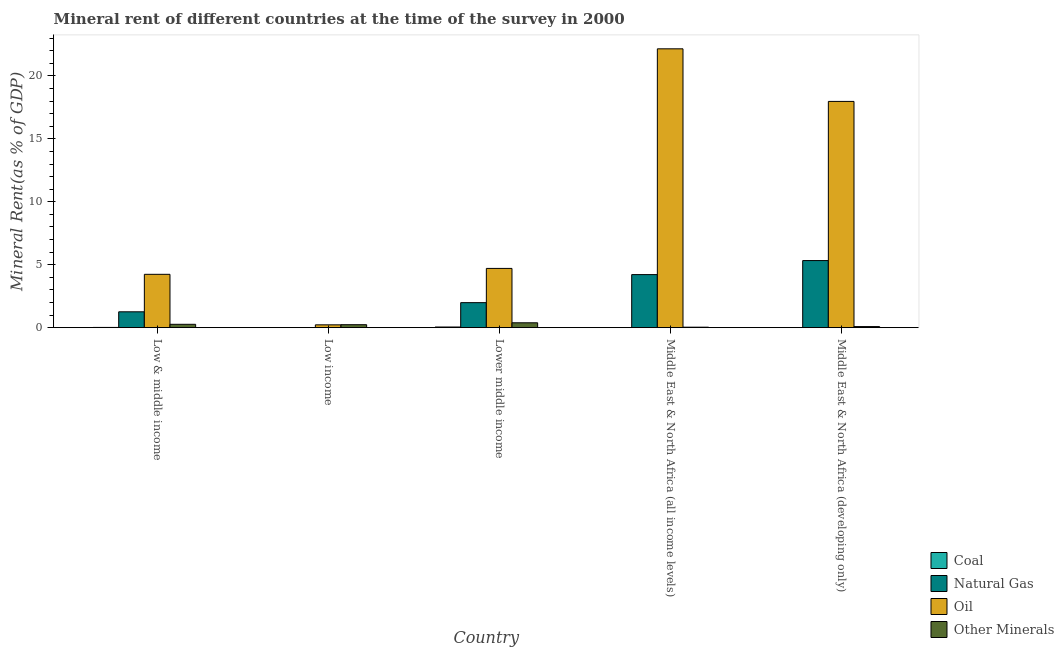Are the number of bars per tick equal to the number of legend labels?
Offer a terse response. Yes. What is the natural gas rent in Middle East & North Africa (developing only)?
Give a very brief answer. 5.33. Across all countries, what is the maximum oil rent?
Make the answer very short. 22.15. Across all countries, what is the minimum  rent of other minerals?
Provide a succinct answer. 0.04. In which country was the oil rent maximum?
Provide a succinct answer. Middle East & North Africa (all income levels). What is the total coal rent in the graph?
Make the answer very short. 0.07. What is the difference between the oil rent in Low & middle income and that in Lower middle income?
Give a very brief answer. -0.47. What is the difference between the natural gas rent in Low income and the  rent of other minerals in Middle East & North Africa (all income levels)?
Provide a short and direct response. -0.04. What is the average natural gas rent per country?
Make the answer very short. 2.56. What is the difference between the coal rent and oil rent in Low & middle income?
Offer a very short reply. -4.22. What is the ratio of the coal rent in Low income to that in Middle East & North Africa (all income levels)?
Offer a very short reply. 0.12. Is the  rent of other minerals in Low & middle income less than that in Middle East & North Africa (all income levels)?
Provide a succinct answer. No. What is the difference between the highest and the second highest oil rent?
Provide a succinct answer. 4.18. What is the difference between the highest and the lowest oil rent?
Offer a very short reply. 21.93. In how many countries, is the coal rent greater than the average coal rent taken over all countries?
Your answer should be compact. 2. Is the sum of the  rent of other minerals in Lower middle income and Middle East & North Africa (all income levels) greater than the maximum coal rent across all countries?
Offer a very short reply. Yes. Is it the case that in every country, the sum of the coal rent and natural gas rent is greater than the sum of  rent of other minerals and oil rent?
Your answer should be compact. No. What does the 3rd bar from the left in Lower middle income represents?
Provide a short and direct response. Oil. What does the 4th bar from the right in Middle East & North Africa (developing only) represents?
Give a very brief answer. Coal. Is it the case that in every country, the sum of the coal rent and natural gas rent is greater than the oil rent?
Your response must be concise. No. How many bars are there?
Ensure brevity in your answer.  20. Does the graph contain grids?
Your response must be concise. No. Where does the legend appear in the graph?
Provide a short and direct response. Bottom right. How are the legend labels stacked?
Provide a short and direct response. Vertical. What is the title of the graph?
Make the answer very short. Mineral rent of different countries at the time of the survey in 2000. Does "Public resource use" appear as one of the legend labels in the graph?
Your response must be concise. No. What is the label or title of the X-axis?
Offer a very short reply. Country. What is the label or title of the Y-axis?
Give a very brief answer. Mineral Rent(as % of GDP). What is the Mineral Rent(as % of GDP) of Coal in Low & middle income?
Give a very brief answer. 0.02. What is the Mineral Rent(as % of GDP) of Natural Gas in Low & middle income?
Provide a short and direct response. 1.26. What is the Mineral Rent(as % of GDP) in Oil in Low & middle income?
Give a very brief answer. 4.24. What is the Mineral Rent(as % of GDP) of Other Minerals in Low & middle income?
Give a very brief answer. 0.27. What is the Mineral Rent(as % of GDP) of Coal in Low income?
Offer a very short reply. 3.43081541094935e-5. What is the Mineral Rent(as % of GDP) of Natural Gas in Low income?
Offer a very short reply. 0. What is the Mineral Rent(as % of GDP) of Oil in Low income?
Your answer should be very brief. 0.22. What is the Mineral Rent(as % of GDP) of Other Minerals in Low income?
Offer a terse response. 0.24. What is the Mineral Rent(as % of GDP) of Coal in Lower middle income?
Keep it short and to the point. 0.05. What is the Mineral Rent(as % of GDP) of Natural Gas in Lower middle income?
Your answer should be very brief. 1.99. What is the Mineral Rent(as % of GDP) in Oil in Lower middle income?
Give a very brief answer. 4.71. What is the Mineral Rent(as % of GDP) in Other Minerals in Lower middle income?
Your answer should be compact. 0.39. What is the Mineral Rent(as % of GDP) in Coal in Middle East & North Africa (all income levels)?
Your answer should be very brief. 0. What is the Mineral Rent(as % of GDP) in Natural Gas in Middle East & North Africa (all income levels)?
Give a very brief answer. 4.22. What is the Mineral Rent(as % of GDP) of Oil in Middle East & North Africa (all income levels)?
Give a very brief answer. 22.15. What is the Mineral Rent(as % of GDP) in Other Minerals in Middle East & North Africa (all income levels)?
Offer a terse response. 0.04. What is the Mineral Rent(as % of GDP) in Coal in Middle East & North Africa (developing only)?
Offer a very short reply. 0. What is the Mineral Rent(as % of GDP) in Natural Gas in Middle East & North Africa (developing only)?
Offer a terse response. 5.33. What is the Mineral Rent(as % of GDP) in Oil in Middle East & North Africa (developing only)?
Offer a very short reply. 17.97. What is the Mineral Rent(as % of GDP) of Other Minerals in Middle East & North Africa (developing only)?
Give a very brief answer. 0.09. Across all countries, what is the maximum Mineral Rent(as % of GDP) in Coal?
Your answer should be very brief. 0.05. Across all countries, what is the maximum Mineral Rent(as % of GDP) of Natural Gas?
Offer a very short reply. 5.33. Across all countries, what is the maximum Mineral Rent(as % of GDP) of Oil?
Keep it short and to the point. 22.15. Across all countries, what is the maximum Mineral Rent(as % of GDP) in Other Minerals?
Give a very brief answer. 0.39. Across all countries, what is the minimum Mineral Rent(as % of GDP) of Coal?
Your answer should be very brief. 3.43081541094935e-5. Across all countries, what is the minimum Mineral Rent(as % of GDP) of Natural Gas?
Give a very brief answer. 0. Across all countries, what is the minimum Mineral Rent(as % of GDP) of Oil?
Your answer should be compact. 0.22. Across all countries, what is the minimum Mineral Rent(as % of GDP) of Other Minerals?
Keep it short and to the point. 0.04. What is the total Mineral Rent(as % of GDP) in Coal in the graph?
Offer a terse response. 0.07. What is the total Mineral Rent(as % of GDP) of Natural Gas in the graph?
Give a very brief answer. 12.79. What is the total Mineral Rent(as % of GDP) in Oil in the graph?
Your response must be concise. 49.3. What is the total Mineral Rent(as % of GDP) of Other Minerals in the graph?
Provide a succinct answer. 1.01. What is the difference between the Mineral Rent(as % of GDP) of Coal in Low & middle income and that in Low income?
Provide a short and direct response. 0.02. What is the difference between the Mineral Rent(as % of GDP) in Natural Gas in Low & middle income and that in Low income?
Make the answer very short. 1.26. What is the difference between the Mineral Rent(as % of GDP) in Oil in Low & middle income and that in Low income?
Give a very brief answer. 4.01. What is the difference between the Mineral Rent(as % of GDP) of Other Minerals in Low & middle income and that in Low income?
Ensure brevity in your answer.  0.03. What is the difference between the Mineral Rent(as % of GDP) of Coal in Low & middle income and that in Lower middle income?
Provide a succinct answer. -0.03. What is the difference between the Mineral Rent(as % of GDP) in Natural Gas in Low & middle income and that in Lower middle income?
Make the answer very short. -0.73. What is the difference between the Mineral Rent(as % of GDP) in Oil in Low & middle income and that in Lower middle income?
Ensure brevity in your answer.  -0.47. What is the difference between the Mineral Rent(as % of GDP) in Other Minerals in Low & middle income and that in Lower middle income?
Keep it short and to the point. -0.12. What is the difference between the Mineral Rent(as % of GDP) in Coal in Low & middle income and that in Middle East & North Africa (all income levels)?
Provide a short and direct response. 0.02. What is the difference between the Mineral Rent(as % of GDP) in Natural Gas in Low & middle income and that in Middle East & North Africa (all income levels)?
Provide a short and direct response. -2.96. What is the difference between the Mineral Rent(as % of GDP) of Oil in Low & middle income and that in Middle East & North Africa (all income levels)?
Provide a succinct answer. -17.91. What is the difference between the Mineral Rent(as % of GDP) of Other Minerals in Low & middle income and that in Middle East & North Africa (all income levels)?
Make the answer very short. 0.23. What is the difference between the Mineral Rent(as % of GDP) of Coal in Low & middle income and that in Middle East & North Africa (developing only)?
Provide a short and direct response. 0.02. What is the difference between the Mineral Rent(as % of GDP) of Natural Gas in Low & middle income and that in Middle East & North Africa (developing only)?
Ensure brevity in your answer.  -4.07. What is the difference between the Mineral Rent(as % of GDP) of Oil in Low & middle income and that in Middle East & North Africa (developing only)?
Provide a short and direct response. -13.74. What is the difference between the Mineral Rent(as % of GDP) in Other Minerals in Low & middle income and that in Middle East & North Africa (developing only)?
Ensure brevity in your answer.  0.18. What is the difference between the Mineral Rent(as % of GDP) of Coal in Low income and that in Lower middle income?
Offer a very short reply. -0.05. What is the difference between the Mineral Rent(as % of GDP) of Natural Gas in Low income and that in Lower middle income?
Offer a very short reply. -1.99. What is the difference between the Mineral Rent(as % of GDP) of Oil in Low income and that in Lower middle income?
Your response must be concise. -4.48. What is the difference between the Mineral Rent(as % of GDP) in Other Minerals in Low income and that in Lower middle income?
Provide a short and direct response. -0.15. What is the difference between the Mineral Rent(as % of GDP) in Coal in Low income and that in Middle East & North Africa (all income levels)?
Offer a very short reply. -0. What is the difference between the Mineral Rent(as % of GDP) of Natural Gas in Low income and that in Middle East & North Africa (all income levels)?
Offer a very short reply. -4.22. What is the difference between the Mineral Rent(as % of GDP) of Oil in Low income and that in Middle East & North Africa (all income levels)?
Provide a succinct answer. -21.93. What is the difference between the Mineral Rent(as % of GDP) in Other Minerals in Low income and that in Middle East & North Africa (all income levels)?
Offer a terse response. 0.2. What is the difference between the Mineral Rent(as % of GDP) in Coal in Low income and that in Middle East & North Africa (developing only)?
Ensure brevity in your answer.  -0. What is the difference between the Mineral Rent(as % of GDP) in Natural Gas in Low income and that in Middle East & North Africa (developing only)?
Your answer should be very brief. -5.33. What is the difference between the Mineral Rent(as % of GDP) of Oil in Low income and that in Middle East & North Africa (developing only)?
Ensure brevity in your answer.  -17.75. What is the difference between the Mineral Rent(as % of GDP) in Other Minerals in Low income and that in Middle East & North Africa (developing only)?
Make the answer very short. 0.15. What is the difference between the Mineral Rent(as % of GDP) of Coal in Lower middle income and that in Middle East & North Africa (all income levels)?
Keep it short and to the point. 0.05. What is the difference between the Mineral Rent(as % of GDP) of Natural Gas in Lower middle income and that in Middle East & North Africa (all income levels)?
Keep it short and to the point. -2.23. What is the difference between the Mineral Rent(as % of GDP) of Oil in Lower middle income and that in Middle East & North Africa (all income levels)?
Your answer should be very brief. -17.45. What is the difference between the Mineral Rent(as % of GDP) of Other Minerals in Lower middle income and that in Middle East & North Africa (all income levels)?
Make the answer very short. 0.35. What is the difference between the Mineral Rent(as % of GDP) in Coal in Lower middle income and that in Middle East & North Africa (developing only)?
Your answer should be compact. 0.05. What is the difference between the Mineral Rent(as % of GDP) of Natural Gas in Lower middle income and that in Middle East & North Africa (developing only)?
Keep it short and to the point. -3.34. What is the difference between the Mineral Rent(as % of GDP) in Oil in Lower middle income and that in Middle East & North Africa (developing only)?
Provide a short and direct response. -13.27. What is the difference between the Mineral Rent(as % of GDP) of Other Minerals in Lower middle income and that in Middle East & North Africa (developing only)?
Make the answer very short. 0.3. What is the difference between the Mineral Rent(as % of GDP) of Coal in Middle East & North Africa (all income levels) and that in Middle East & North Africa (developing only)?
Offer a very short reply. -0. What is the difference between the Mineral Rent(as % of GDP) of Natural Gas in Middle East & North Africa (all income levels) and that in Middle East & North Africa (developing only)?
Keep it short and to the point. -1.12. What is the difference between the Mineral Rent(as % of GDP) in Oil in Middle East & North Africa (all income levels) and that in Middle East & North Africa (developing only)?
Offer a terse response. 4.18. What is the difference between the Mineral Rent(as % of GDP) in Other Minerals in Middle East & North Africa (all income levels) and that in Middle East & North Africa (developing only)?
Your answer should be compact. -0.05. What is the difference between the Mineral Rent(as % of GDP) in Coal in Low & middle income and the Mineral Rent(as % of GDP) in Natural Gas in Low income?
Offer a terse response. 0.02. What is the difference between the Mineral Rent(as % of GDP) in Coal in Low & middle income and the Mineral Rent(as % of GDP) in Oil in Low income?
Your answer should be compact. -0.21. What is the difference between the Mineral Rent(as % of GDP) of Coal in Low & middle income and the Mineral Rent(as % of GDP) of Other Minerals in Low income?
Ensure brevity in your answer.  -0.22. What is the difference between the Mineral Rent(as % of GDP) of Natural Gas in Low & middle income and the Mineral Rent(as % of GDP) of Oil in Low income?
Your response must be concise. 1.04. What is the difference between the Mineral Rent(as % of GDP) in Natural Gas in Low & middle income and the Mineral Rent(as % of GDP) in Other Minerals in Low income?
Make the answer very short. 1.02. What is the difference between the Mineral Rent(as % of GDP) in Oil in Low & middle income and the Mineral Rent(as % of GDP) in Other Minerals in Low income?
Your response must be concise. 4. What is the difference between the Mineral Rent(as % of GDP) of Coal in Low & middle income and the Mineral Rent(as % of GDP) of Natural Gas in Lower middle income?
Offer a terse response. -1.97. What is the difference between the Mineral Rent(as % of GDP) of Coal in Low & middle income and the Mineral Rent(as % of GDP) of Oil in Lower middle income?
Your response must be concise. -4.69. What is the difference between the Mineral Rent(as % of GDP) in Coal in Low & middle income and the Mineral Rent(as % of GDP) in Other Minerals in Lower middle income?
Offer a terse response. -0.37. What is the difference between the Mineral Rent(as % of GDP) in Natural Gas in Low & middle income and the Mineral Rent(as % of GDP) in Oil in Lower middle income?
Your answer should be very brief. -3.45. What is the difference between the Mineral Rent(as % of GDP) in Natural Gas in Low & middle income and the Mineral Rent(as % of GDP) in Other Minerals in Lower middle income?
Provide a succinct answer. 0.87. What is the difference between the Mineral Rent(as % of GDP) in Oil in Low & middle income and the Mineral Rent(as % of GDP) in Other Minerals in Lower middle income?
Offer a very short reply. 3.85. What is the difference between the Mineral Rent(as % of GDP) in Coal in Low & middle income and the Mineral Rent(as % of GDP) in Natural Gas in Middle East & North Africa (all income levels)?
Provide a short and direct response. -4.2. What is the difference between the Mineral Rent(as % of GDP) in Coal in Low & middle income and the Mineral Rent(as % of GDP) in Oil in Middle East & North Africa (all income levels)?
Ensure brevity in your answer.  -22.13. What is the difference between the Mineral Rent(as % of GDP) in Coal in Low & middle income and the Mineral Rent(as % of GDP) in Other Minerals in Middle East & North Africa (all income levels)?
Provide a short and direct response. -0.02. What is the difference between the Mineral Rent(as % of GDP) in Natural Gas in Low & middle income and the Mineral Rent(as % of GDP) in Oil in Middle East & North Africa (all income levels)?
Your answer should be very brief. -20.89. What is the difference between the Mineral Rent(as % of GDP) of Natural Gas in Low & middle income and the Mineral Rent(as % of GDP) of Other Minerals in Middle East & North Africa (all income levels)?
Your response must be concise. 1.22. What is the difference between the Mineral Rent(as % of GDP) in Oil in Low & middle income and the Mineral Rent(as % of GDP) in Other Minerals in Middle East & North Africa (all income levels)?
Offer a very short reply. 4.2. What is the difference between the Mineral Rent(as % of GDP) of Coal in Low & middle income and the Mineral Rent(as % of GDP) of Natural Gas in Middle East & North Africa (developing only)?
Make the answer very short. -5.31. What is the difference between the Mineral Rent(as % of GDP) in Coal in Low & middle income and the Mineral Rent(as % of GDP) in Oil in Middle East & North Africa (developing only)?
Give a very brief answer. -17.96. What is the difference between the Mineral Rent(as % of GDP) in Coal in Low & middle income and the Mineral Rent(as % of GDP) in Other Minerals in Middle East & North Africa (developing only)?
Ensure brevity in your answer.  -0.07. What is the difference between the Mineral Rent(as % of GDP) in Natural Gas in Low & middle income and the Mineral Rent(as % of GDP) in Oil in Middle East & North Africa (developing only)?
Give a very brief answer. -16.71. What is the difference between the Mineral Rent(as % of GDP) of Natural Gas in Low & middle income and the Mineral Rent(as % of GDP) of Other Minerals in Middle East & North Africa (developing only)?
Keep it short and to the point. 1.17. What is the difference between the Mineral Rent(as % of GDP) in Oil in Low & middle income and the Mineral Rent(as % of GDP) in Other Minerals in Middle East & North Africa (developing only)?
Offer a very short reply. 4.15. What is the difference between the Mineral Rent(as % of GDP) of Coal in Low income and the Mineral Rent(as % of GDP) of Natural Gas in Lower middle income?
Keep it short and to the point. -1.99. What is the difference between the Mineral Rent(as % of GDP) in Coal in Low income and the Mineral Rent(as % of GDP) in Oil in Lower middle income?
Provide a succinct answer. -4.71. What is the difference between the Mineral Rent(as % of GDP) of Coal in Low income and the Mineral Rent(as % of GDP) of Other Minerals in Lower middle income?
Your answer should be compact. -0.39. What is the difference between the Mineral Rent(as % of GDP) in Natural Gas in Low income and the Mineral Rent(as % of GDP) in Oil in Lower middle income?
Your answer should be very brief. -4.71. What is the difference between the Mineral Rent(as % of GDP) in Natural Gas in Low income and the Mineral Rent(as % of GDP) in Other Minerals in Lower middle income?
Provide a succinct answer. -0.39. What is the difference between the Mineral Rent(as % of GDP) in Oil in Low income and the Mineral Rent(as % of GDP) in Other Minerals in Lower middle income?
Ensure brevity in your answer.  -0.16. What is the difference between the Mineral Rent(as % of GDP) of Coal in Low income and the Mineral Rent(as % of GDP) of Natural Gas in Middle East & North Africa (all income levels)?
Keep it short and to the point. -4.22. What is the difference between the Mineral Rent(as % of GDP) in Coal in Low income and the Mineral Rent(as % of GDP) in Oil in Middle East & North Africa (all income levels)?
Your response must be concise. -22.15. What is the difference between the Mineral Rent(as % of GDP) in Coal in Low income and the Mineral Rent(as % of GDP) in Other Minerals in Middle East & North Africa (all income levels)?
Offer a very short reply. -0.04. What is the difference between the Mineral Rent(as % of GDP) of Natural Gas in Low income and the Mineral Rent(as % of GDP) of Oil in Middle East & North Africa (all income levels)?
Your answer should be compact. -22.15. What is the difference between the Mineral Rent(as % of GDP) in Natural Gas in Low income and the Mineral Rent(as % of GDP) in Other Minerals in Middle East & North Africa (all income levels)?
Your answer should be very brief. -0.04. What is the difference between the Mineral Rent(as % of GDP) in Oil in Low income and the Mineral Rent(as % of GDP) in Other Minerals in Middle East & North Africa (all income levels)?
Provide a short and direct response. 0.19. What is the difference between the Mineral Rent(as % of GDP) in Coal in Low income and the Mineral Rent(as % of GDP) in Natural Gas in Middle East & North Africa (developing only)?
Make the answer very short. -5.33. What is the difference between the Mineral Rent(as % of GDP) of Coal in Low income and the Mineral Rent(as % of GDP) of Oil in Middle East & North Africa (developing only)?
Ensure brevity in your answer.  -17.97. What is the difference between the Mineral Rent(as % of GDP) of Coal in Low income and the Mineral Rent(as % of GDP) of Other Minerals in Middle East & North Africa (developing only)?
Your response must be concise. -0.09. What is the difference between the Mineral Rent(as % of GDP) of Natural Gas in Low income and the Mineral Rent(as % of GDP) of Oil in Middle East & North Africa (developing only)?
Provide a short and direct response. -17.97. What is the difference between the Mineral Rent(as % of GDP) of Natural Gas in Low income and the Mineral Rent(as % of GDP) of Other Minerals in Middle East & North Africa (developing only)?
Offer a terse response. -0.09. What is the difference between the Mineral Rent(as % of GDP) in Oil in Low income and the Mineral Rent(as % of GDP) in Other Minerals in Middle East & North Africa (developing only)?
Your answer should be compact. 0.14. What is the difference between the Mineral Rent(as % of GDP) in Coal in Lower middle income and the Mineral Rent(as % of GDP) in Natural Gas in Middle East & North Africa (all income levels)?
Provide a short and direct response. -4.16. What is the difference between the Mineral Rent(as % of GDP) in Coal in Lower middle income and the Mineral Rent(as % of GDP) in Oil in Middle East & North Africa (all income levels)?
Offer a terse response. -22.1. What is the difference between the Mineral Rent(as % of GDP) in Coal in Lower middle income and the Mineral Rent(as % of GDP) in Other Minerals in Middle East & North Africa (all income levels)?
Your answer should be very brief. 0.01. What is the difference between the Mineral Rent(as % of GDP) of Natural Gas in Lower middle income and the Mineral Rent(as % of GDP) of Oil in Middle East & North Africa (all income levels)?
Make the answer very short. -20.17. What is the difference between the Mineral Rent(as % of GDP) in Natural Gas in Lower middle income and the Mineral Rent(as % of GDP) in Other Minerals in Middle East & North Africa (all income levels)?
Provide a short and direct response. 1.95. What is the difference between the Mineral Rent(as % of GDP) of Oil in Lower middle income and the Mineral Rent(as % of GDP) of Other Minerals in Middle East & North Africa (all income levels)?
Offer a very short reply. 4.67. What is the difference between the Mineral Rent(as % of GDP) in Coal in Lower middle income and the Mineral Rent(as % of GDP) in Natural Gas in Middle East & North Africa (developing only)?
Your answer should be compact. -5.28. What is the difference between the Mineral Rent(as % of GDP) of Coal in Lower middle income and the Mineral Rent(as % of GDP) of Oil in Middle East & North Africa (developing only)?
Provide a succinct answer. -17.92. What is the difference between the Mineral Rent(as % of GDP) of Coal in Lower middle income and the Mineral Rent(as % of GDP) of Other Minerals in Middle East & North Africa (developing only)?
Your answer should be very brief. -0.03. What is the difference between the Mineral Rent(as % of GDP) of Natural Gas in Lower middle income and the Mineral Rent(as % of GDP) of Oil in Middle East & North Africa (developing only)?
Provide a succinct answer. -15.99. What is the difference between the Mineral Rent(as % of GDP) in Natural Gas in Lower middle income and the Mineral Rent(as % of GDP) in Other Minerals in Middle East & North Africa (developing only)?
Provide a short and direct response. 1.9. What is the difference between the Mineral Rent(as % of GDP) in Oil in Lower middle income and the Mineral Rent(as % of GDP) in Other Minerals in Middle East & North Africa (developing only)?
Give a very brief answer. 4.62. What is the difference between the Mineral Rent(as % of GDP) in Coal in Middle East & North Africa (all income levels) and the Mineral Rent(as % of GDP) in Natural Gas in Middle East & North Africa (developing only)?
Offer a very short reply. -5.33. What is the difference between the Mineral Rent(as % of GDP) of Coal in Middle East & North Africa (all income levels) and the Mineral Rent(as % of GDP) of Oil in Middle East & North Africa (developing only)?
Provide a short and direct response. -17.97. What is the difference between the Mineral Rent(as % of GDP) in Coal in Middle East & North Africa (all income levels) and the Mineral Rent(as % of GDP) in Other Minerals in Middle East & North Africa (developing only)?
Ensure brevity in your answer.  -0.08. What is the difference between the Mineral Rent(as % of GDP) in Natural Gas in Middle East & North Africa (all income levels) and the Mineral Rent(as % of GDP) in Oil in Middle East & North Africa (developing only)?
Provide a short and direct response. -13.76. What is the difference between the Mineral Rent(as % of GDP) in Natural Gas in Middle East & North Africa (all income levels) and the Mineral Rent(as % of GDP) in Other Minerals in Middle East & North Africa (developing only)?
Your answer should be compact. 4.13. What is the difference between the Mineral Rent(as % of GDP) of Oil in Middle East & North Africa (all income levels) and the Mineral Rent(as % of GDP) of Other Minerals in Middle East & North Africa (developing only)?
Provide a succinct answer. 22.07. What is the average Mineral Rent(as % of GDP) in Coal per country?
Your answer should be very brief. 0.01. What is the average Mineral Rent(as % of GDP) in Natural Gas per country?
Give a very brief answer. 2.56. What is the average Mineral Rent(as % of GDP) in Oil per country?
Your answer should be very brief. 9.86. What is the average Mineral Rent(as % of GDP) of Other Minerals per country?
Provide a succinct answer. 0.2. What is the difference between the Mineral Rent(as % of GDP) of Coal and Mineral Rent(as % of GDP) of Natural Gas in Low & middle income?
Ensure brevity in your answer.  -1.24. What is the difference between the Mineral Rent(as % of GDP) in Coal and Mineral Rent(as % of GDP) in Oil in Low & middle income?
Offer a terse response. -4.22. What is the difference between the Mineral Rent(as % of GDP) of Coal and Mineral Rent(as % of GDP) of Other Minerals in Low & middle income?
Offer a terse response. -0.25. What is the difference between the Mineral Rent(as % of GDP) of Natural Gas and Mineral Rent(as % of GDP) of Oil in Low & middle income?
Your response must be concise. -2.98. What is the difference between the Mineral Rent(as % of GDP) of Natural Gas and Mineral Rent(as % of GDP) of Other Minerals in Low & middle income?
Make the answer very short. 0.99. What is the difference between the Mineral Rent(as % of GDP) of Oil and Mineral Rent(as % of GDP) of Other Minerals in Low & middle income?
Keep it short and to the point. 3.97. What is the difference between the Mineral Rent(as % of GDP) in Coal and Mineral Rent(as % of GDP) in Natural Gas in Low income?
Ensure brevity in your answer.  -0. What is the difference between the Mineral Rent(as % of GDP) in Coal and Mineral Rent(as % of GDP) in Oil in Low income?
Offer a very short reply. -0.22. What is the difference between the Mineral Rent(as % of GDP) in Coal and Mineral Rent(as % of GDP) in Other Minerals in Low income?
Provide a succinct answer. -0.24. What is the difference between the Mineral Rent(as % of GDP) in Natural Gas and Mineral Rent(as % of GDP) in Oil in Low income?
Give a very brief answer. -0.22. What is the difference between the Mineral Rent(as % of GDP) of Natural Gas and Mineral Rent(as % of GDP) of Other Minerals in Low income?
Give a very brief answer. -0.24. What is the difference between the Mineral Rent(as % of GDP) of Oil and Mineral Rent(as % of GDP) of Other Minerals in Low income?
Make the answer very short. -0.01. What is the difference between the Mineral Rent(as % of GDP) of Coal and Mineral Rent(as % of GDP) of Natural Gas in Lower middle income?
Provide a short and direct response. -1.93. What is the difference between the Mineral Rent(as % of GDP) in Coal and Mineral Rent(as % of GDP) in Oil in Lower middle income?
Offer a terse response. -4.65. What is the difference between the Mineral Rent(as % of GDP) of Coal and Mineral Rent(as % of GDP) of Other Minerals in Lower middle income?
Make the answer very short. -0.33. What is the difference between the Mineral Rent(as % of GDP) in Natural Gas and Mineral Rent(as % of GDP) in Oil in Lower middle income?
Your answer should be very brief. -2.72. What is the difference between the Mineral Rent(as % of GDP) in Natural Gas and Mineral Rent(as % of GDP) in Other Minerals in Lower middle income?
Your answer should be very brief. 1.6. What is the difference between the Mineral Rent(as % of GDP) of Oil and Mineral Rent(as % of GDP) of Other Minerals in Lower middle income?
Keep it short and to the point. 4.32. What is the difference between the Mineral Rent(as % of GDP) of Coal and Mineral Rent(as % of GDP) of Natural Gas in Middle East & North Africa (all income levels)?
Your response must be concise. -4.22. What is the difference between the Mineral Rent(as % of GDP) of Coal and Mineral Rent(as % of GDP) of Oil in Middle East & North Africa (all income levels)?
Give a very brief answer. -22.15. What is the difference between the Mineral Rent(as % of GDP) in Coal and Mineral Rent(as % of GDP) in Other Minerals in Middle East & North Africa (all income levels)?
Provide a succinct answer. -0.04. What is the difference between the Mineral Rent(as % of GDP) of Natural Gas and Mineral Rent(as % of GDP) of Oil in Middle East & North Africa (all income levels)?
Provide a succinct answer. -17.94. What is the difference between the Mineral Rent(as % of GDP) of Natural Gas and Mineral Rent(as % of GDP) of Other Minerals in Middle East & North Africa (all income levels)?
Ensure brevity in your answer.  4.18. What is the difference between the Mineral Rent(as % of GDP) of Oil and Mineral Rent(as % of GDP) of Other Minerals in Middle East & North Africa (all income levels)?
Your answer should be very brief. 22.11. What is the difference between the Mineral Rent(as % of GDP) in Coal and Mineral Rent(as % of GDP) in Natural Gas in Middle East & North Africa (developing only)?
Offer a terse response. -5.33. What is the difference between the Mineral Rent(as % of GDP) of Coal and Mineral Rent(as % of GDP) of Oil in Middle East & North Africa (developing only)?
Ensure brevity in your answer.  -17.97. What is the difference between the Mineral Rent(as % of GDP) in Coal and Mineral Rent(as % of GDP) in Other Minerals in Middle East & North Africa (developing only)?
Your answer should be very brief. -0.08. What is the difference between the Mineral Rent(as % of GDP) in Natural Gas and Mineral Rent(as % of GDP) in Oil in Middle East & North Africa (developing only)?
Provide a succinct answer. -12.64. What is the difference between the Mineral Rent(as % of GDP) in Natural Gas and Mineral Rent(as % of GDP) in Other Minerals in Middle East & North Africa (developing only)?
Provide a succinct answer. 5.25. What is the difference between the Mineral Rent(as % of GDP) in Oil and Mineral Rent(as % of GDP) in Other Minerals in Middle East & North Africa (developing only)?
Your response must be concise. 17.89. What is the ratio of the Mineral Rent(as % of GDP) in Coal in Low & middle income to that in Low income?
Make the answer very short. 547.49. What is the ratio of the Mineral Rent(as % of GDP) of Natural Gas in Low & middle income to that in Low income?
Provide a short and direct response. 8492.11. What is the ratio of the Mineral Rent(as % of GDP) in Oil in Low & middle income to that in Low income?
Provide a succinct answer. 18.89. What is the ratio of the Mineral Rent(as % of GDP) in Other Minerals in Low & middle income to that in Low income?
Ensure brevity in your answer.  1.13. What is the ratio of the Mineral Rent(as % of GDP) in Coal in Low & middle income to that in Lower middle income?
Give a very brief answer. 0.36. What is the ratio of the Mineral Rent(as % of GDP) of Natural Gas in Low & middle income to that in Lower middle income?
Offer a terse response. 0.63. What is the ratio of the Mineral Rent(as % of GDP) in Oil in Low & middle income to that in Lower middle income?
Provide a short and direct response. 0.9. What is the ratio of the Mineral Rent(as % of GDP) in Other Minerals in Low & middle income to that in Lower middle income?
Your answer should be compact. 0.69. What is the ratio of the Mineral Rent(as % of GDP) in Coal in Low & middle income to that in Middle East & North Africa (all income levels)?
Provide a succinct answer. 65.83. What is the ratio of the Mineral Rent(as % of GDP) of Natural Gas in Low & middle income to that in Middle East & North Africa (all income levels)?
Offer a very short reply. 0.3. What is the ratio of the Mineral Rent(as % of GDP) in Oil in Low & middle income to that in Middle East & North Africa (all income levels)?
Your response must be concise. 0.19. What is the ratio of the Mineral Rent(as % of GDP) in Other Minerals in Low & middle income to that in Middle East & North Africa (all income levels)?
Provide a succinct answer. 6.92. What is the ratio of the Mineral Rent(as % of GDP) in Coal in Low & middle income to that in Middle East & North Africa (developing only)?
Your answer should be compact. 29.65. What is the ratio of the Mineral Rent(as % of GDP) of Natural Gas in Low & middle income to that in Middle East & North Africa (developing only)?
Your answer should be very brief. 0.24. What is the ratio of the Mineral Rent(as % of GDP) in Oil in Low & middle income to that in Middle East & North Africa (developing only)?
Your answer should be compact. 0.24. What is the ratio of the Mineral Rent(as % of GDP) of Other Minerals in Low & middle income to that in Middle East & North Africa (developing only)?
Provide a short and direct response. 3.13. What is the ratio of the Mineral Rent(as % of GDP) in Coal in Low income to that in Lower middle income?
Provide a short and direct response. 0. What is the ratio of the Mineral Rent(as % of GDP) of Oil in Low income to that in Lower middle income?
Ensure brevity in your answer.  0.05. What is the ratio of the Mineral Rent(as % of GDP) of Other Minerals in Low income to that in Lower middle income?
Offer a terse response. 0.61. What is the ratio of the Mineral Rent(as % of GDP) of Coal in Low income to that in Middle East & North Africa (all income levels)?
Your answer should be compact. 0.12. What is the ratio of the Mineral Rent(as % of GDP) in Oil in Low income to that in Middle East & North Africa (all income levels)?
Provide a short and direct response. 0.01. What is the ratio of the Mineral Rent(as % of GDP) of Other Minerals in Low income to that in Middle East & North Africa (all income levels)?
Make the answer very short. 6.14. What is the ratio of the Mineral Rent(as % of GDP) of Coal in Low income to that in Middle East & North Africa (developing only)?
Your answer should be compact. 0.05. What is the ratio of the Mineral Rent(as % of GDP) of Natural Gas in Low income to that in Middle East & North Africa (developing only)?
Keep it short and to the point. 0. What is the ratio of the Mineral Rent(as % of GDP) in Oil in Low income to that in Middle East & North Africa (developing only)?
Provide a succinct answer. 0.01. What is the ratio of the Mineral Rent(as % of GDP) of Other Minerals in Low income to that in Middle East & North Africa (developing only)?
Ensure brevity in your answer.  2.78. What is the ratio of the Mineral Rent(as % of GDP) of Coal in Lower middle income to that in Middle East & North Africa (all income levels)?
Your answer should be compact. 183. What is the ratio of the Mineral Rent(as % of GDP) in Natural Gas in Lower middle income to that in Middle East & North Africa (all income levels)?
Your answer should be compact. 0.47. What is the ratio of the Mineral Rent(as % of GDP) in Oil in Lower middle income to that in Middle East & North Africa (all income levels)?
Provide a succinct answer. 0.21. What is the ratio of the Mineral Rent(as % of GDP) of Other Minerals in Lower middle income to that in Middle East & North Africa (all income levels)?
Ensure brevity in your answer.  10.05. What is the ratio of the Mineral Rent(as % of GDP) in Coal in Lower middle income to that in Middle East & North Africa (developing only)?
Offer a very short reply. 82.42. What is the ratio of the Mineral Rent(as % of GDP) in Natural Gas in Lower middle income to that in Middle East & North Africa (developing only)?
Provide a succinct answer. 0.37. What is the ratio of the Mineral Rent(as % of GDP) in Oil in Lower middle income to that in Middle East & North Africa (developing only)?
Your answer should be compact. 0.26. What is the ratio of the Mineral Rent(as % of GDP) in Other Minerals in Lower middle income to that in Middle East & North Africa (developing only)?
Ensure brevity in your answer.  4.54. What is the ratio of the Mineral Rent(as % of GDP) in Coal in Middle East & North Africa (all income levels) to that in Middle East & North Africa (developing only)?
Give a very brief answer. 0.45. What is the ratio of the Mineral Rent(as % of GDP) of Natural Gas in Middle East & North Africa (all income levels) to that in Middle East & North Africa (developing only)?
Keep it short and to the point. 0.79. What is the ratio of the Mineral Rent(as % of GDP) in Oil in Middle East & North Africa (all income levels) to that in Middle East & North Africa (developing only)?
Ensure brevity in your answer.  1.23. What is the ratio of the Mineral Rent(as % of GDP) of Other Minerals in Middle East & North Africa (all income levels) to that in Middle East & North Africa (developing only)?
Provide a short and direct response. 0.45. What is the difference between the highest and the second highest Mineral Rent(as % of GDP) in Coal?
Offer a terse response. 0.03. What is the difference between the highest and the second highest Mineral Rent(as % of GDP) of Natural Gas?
Keep it short and to the point. 1.12. What is the difference between the highest and the second highest Mineral Rent(as % of GDP) of Oil?
Your answer should be very brief. 4.18. What is the difference between the highest and the second highest Mineral Rent(as % of GDP) in Other Minerals?
Give a very brief answer. 0.12. What is the difference between the highest and the lowest Mineral Rent(as % of GDP) of Coal?
Keep it short and to the point. 0.05. What is the difference between the highest and the lowest Mineral Rent(as % of GDP) in Natural Gas?
Give a very brief answer. 5.33. What is the difference between the highest and the lowest Mineral Rent(as % of GDP) in Oil?
Provide a succinct answer. 21.93. What is the difference between the highest and the lowest Mineral Rent(as % of GDP) in Other Minerals?
Give a very brief answer. 0.35. 